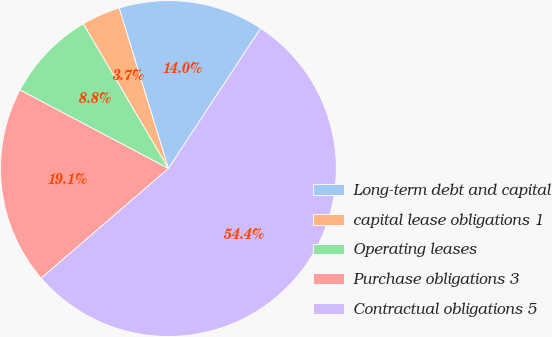Convert chart. <chart><loc_0><loc_0><loc_500><loc_500><pie_chart><fcel>Long-term debt and capital<fcel>capital lease obligations 1<fcel>Operating leases<fcel>Purchase obligations 3<fcel>Contractual obligations 5<nl><fcel>14.0%<fcel>3.72%<fcel>8.79%<fcel>19.07%<fcel>54.42%<nl></chart> 